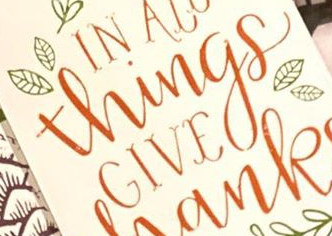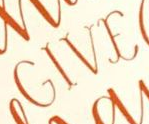Read the text content from these images in order, separated by a semicolon. Things; GIVE 